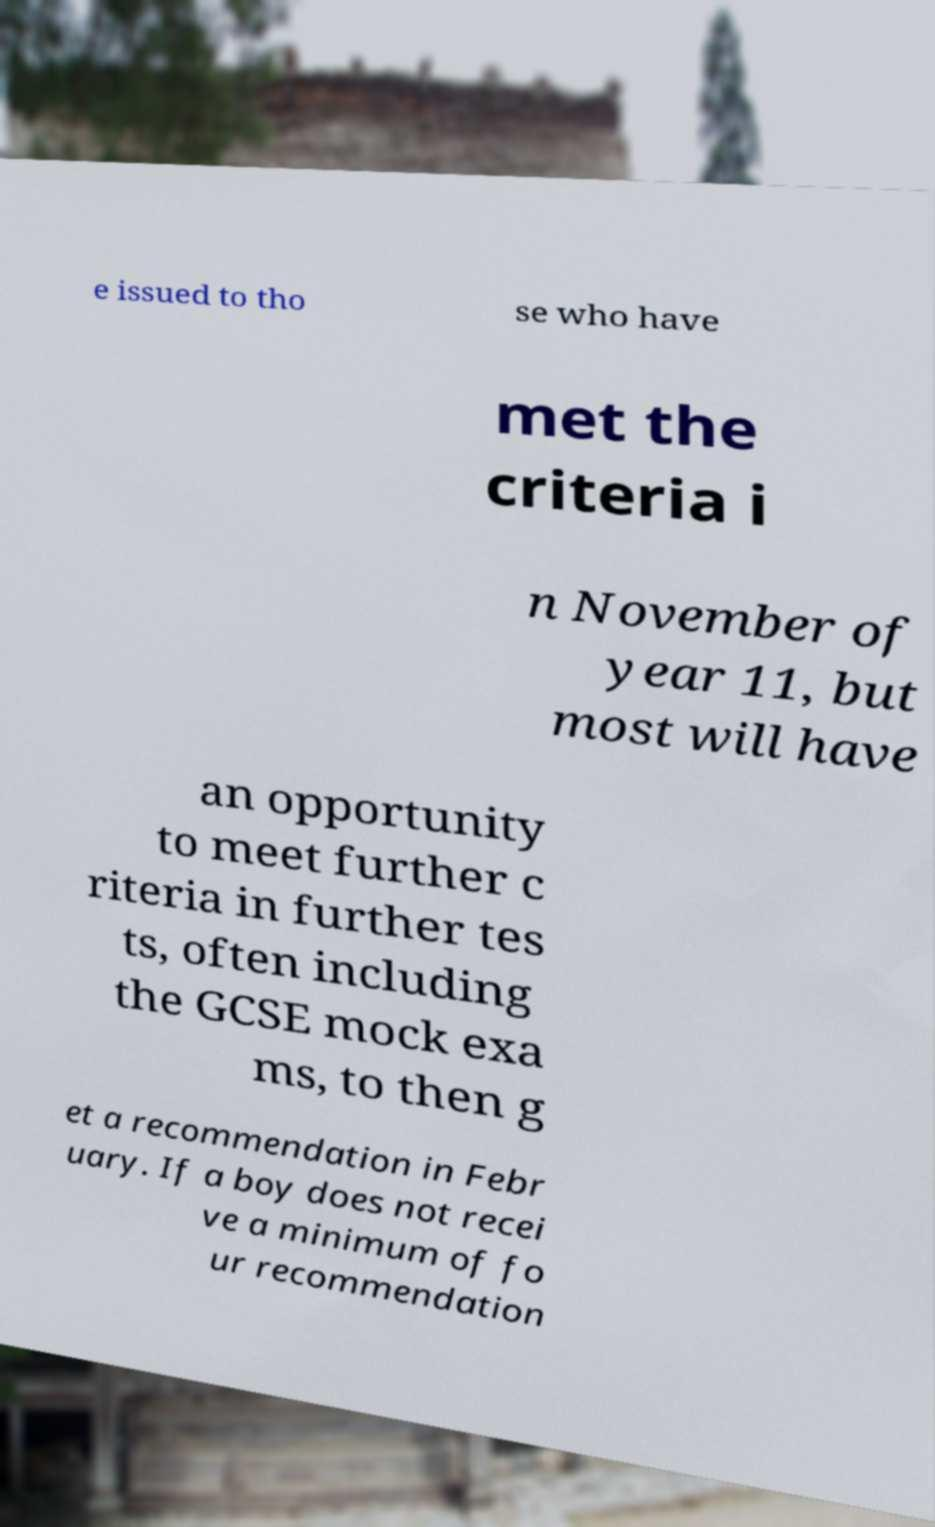Can you read and provide the text displayed in the image?This photo seems to have some interesting text. Can you extract and type it out for me? e issued to tho se who have met the criteria i n November of year 11, but most will have an opportunity to meet further c riteria in further tes ts, often including the GCSE mock exa ms, to then g et a recommendation in Febr uary. If a boy does not recei ve a minimum of fo ur recommendation 